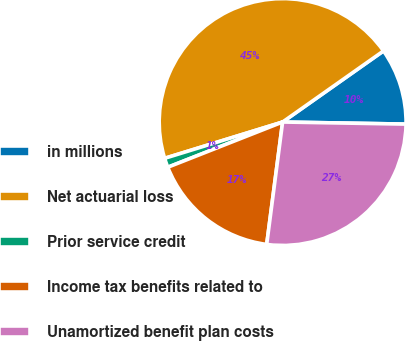<chart> <loc_0><loc_0><loc_500><loc_500><pie_chart><fcel>in millions<fcel>Net actuarial loss<fcel>Prior service credit<fcel>Income tax benefits related to<fcel>Unamortized benefit plan costs<nl><fcel>10.04%<fcel>44.98%<fcel>1.22%<fcel>16.97%<fcel>26.79%<nl></chart> 